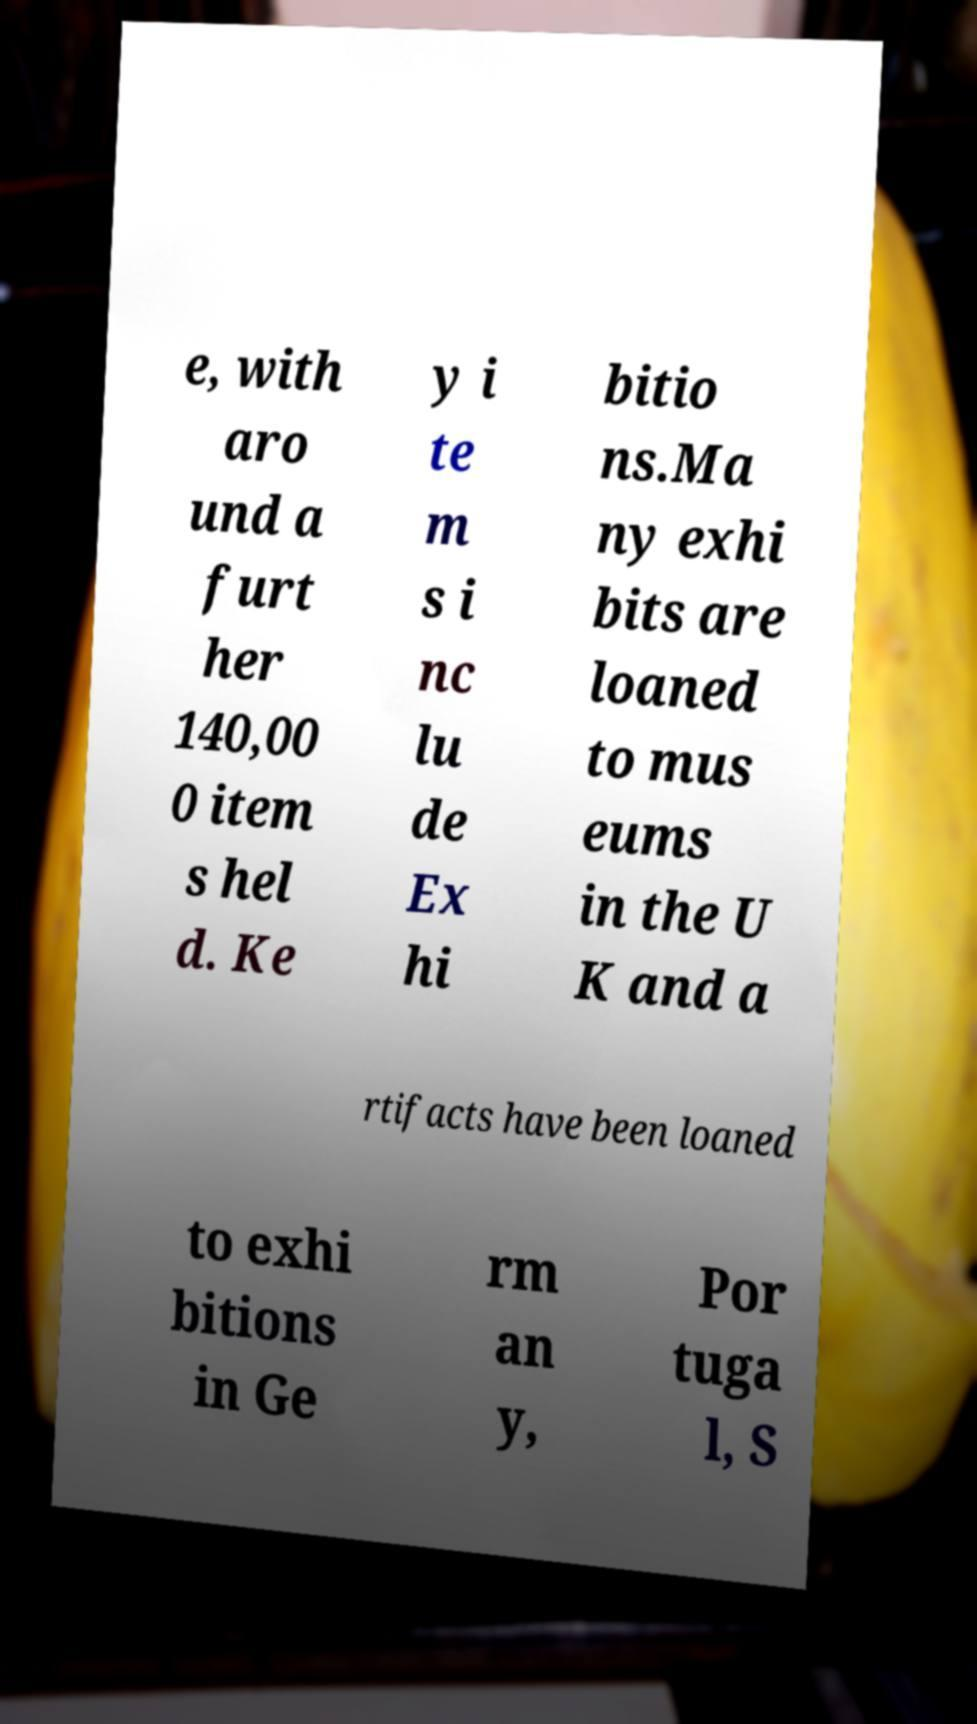Please identify and transcribe the text found in this image. e, with aro und a furt her 140,00 0 item s hel d. Ke y i te m s i nc lu de Ex hi bitio ns.Ma ny exhi bits are loaned to mus eums in the U K and a rtifacts have been loaned to exhi bitions in Ge rm an y, Por tuga l, S 